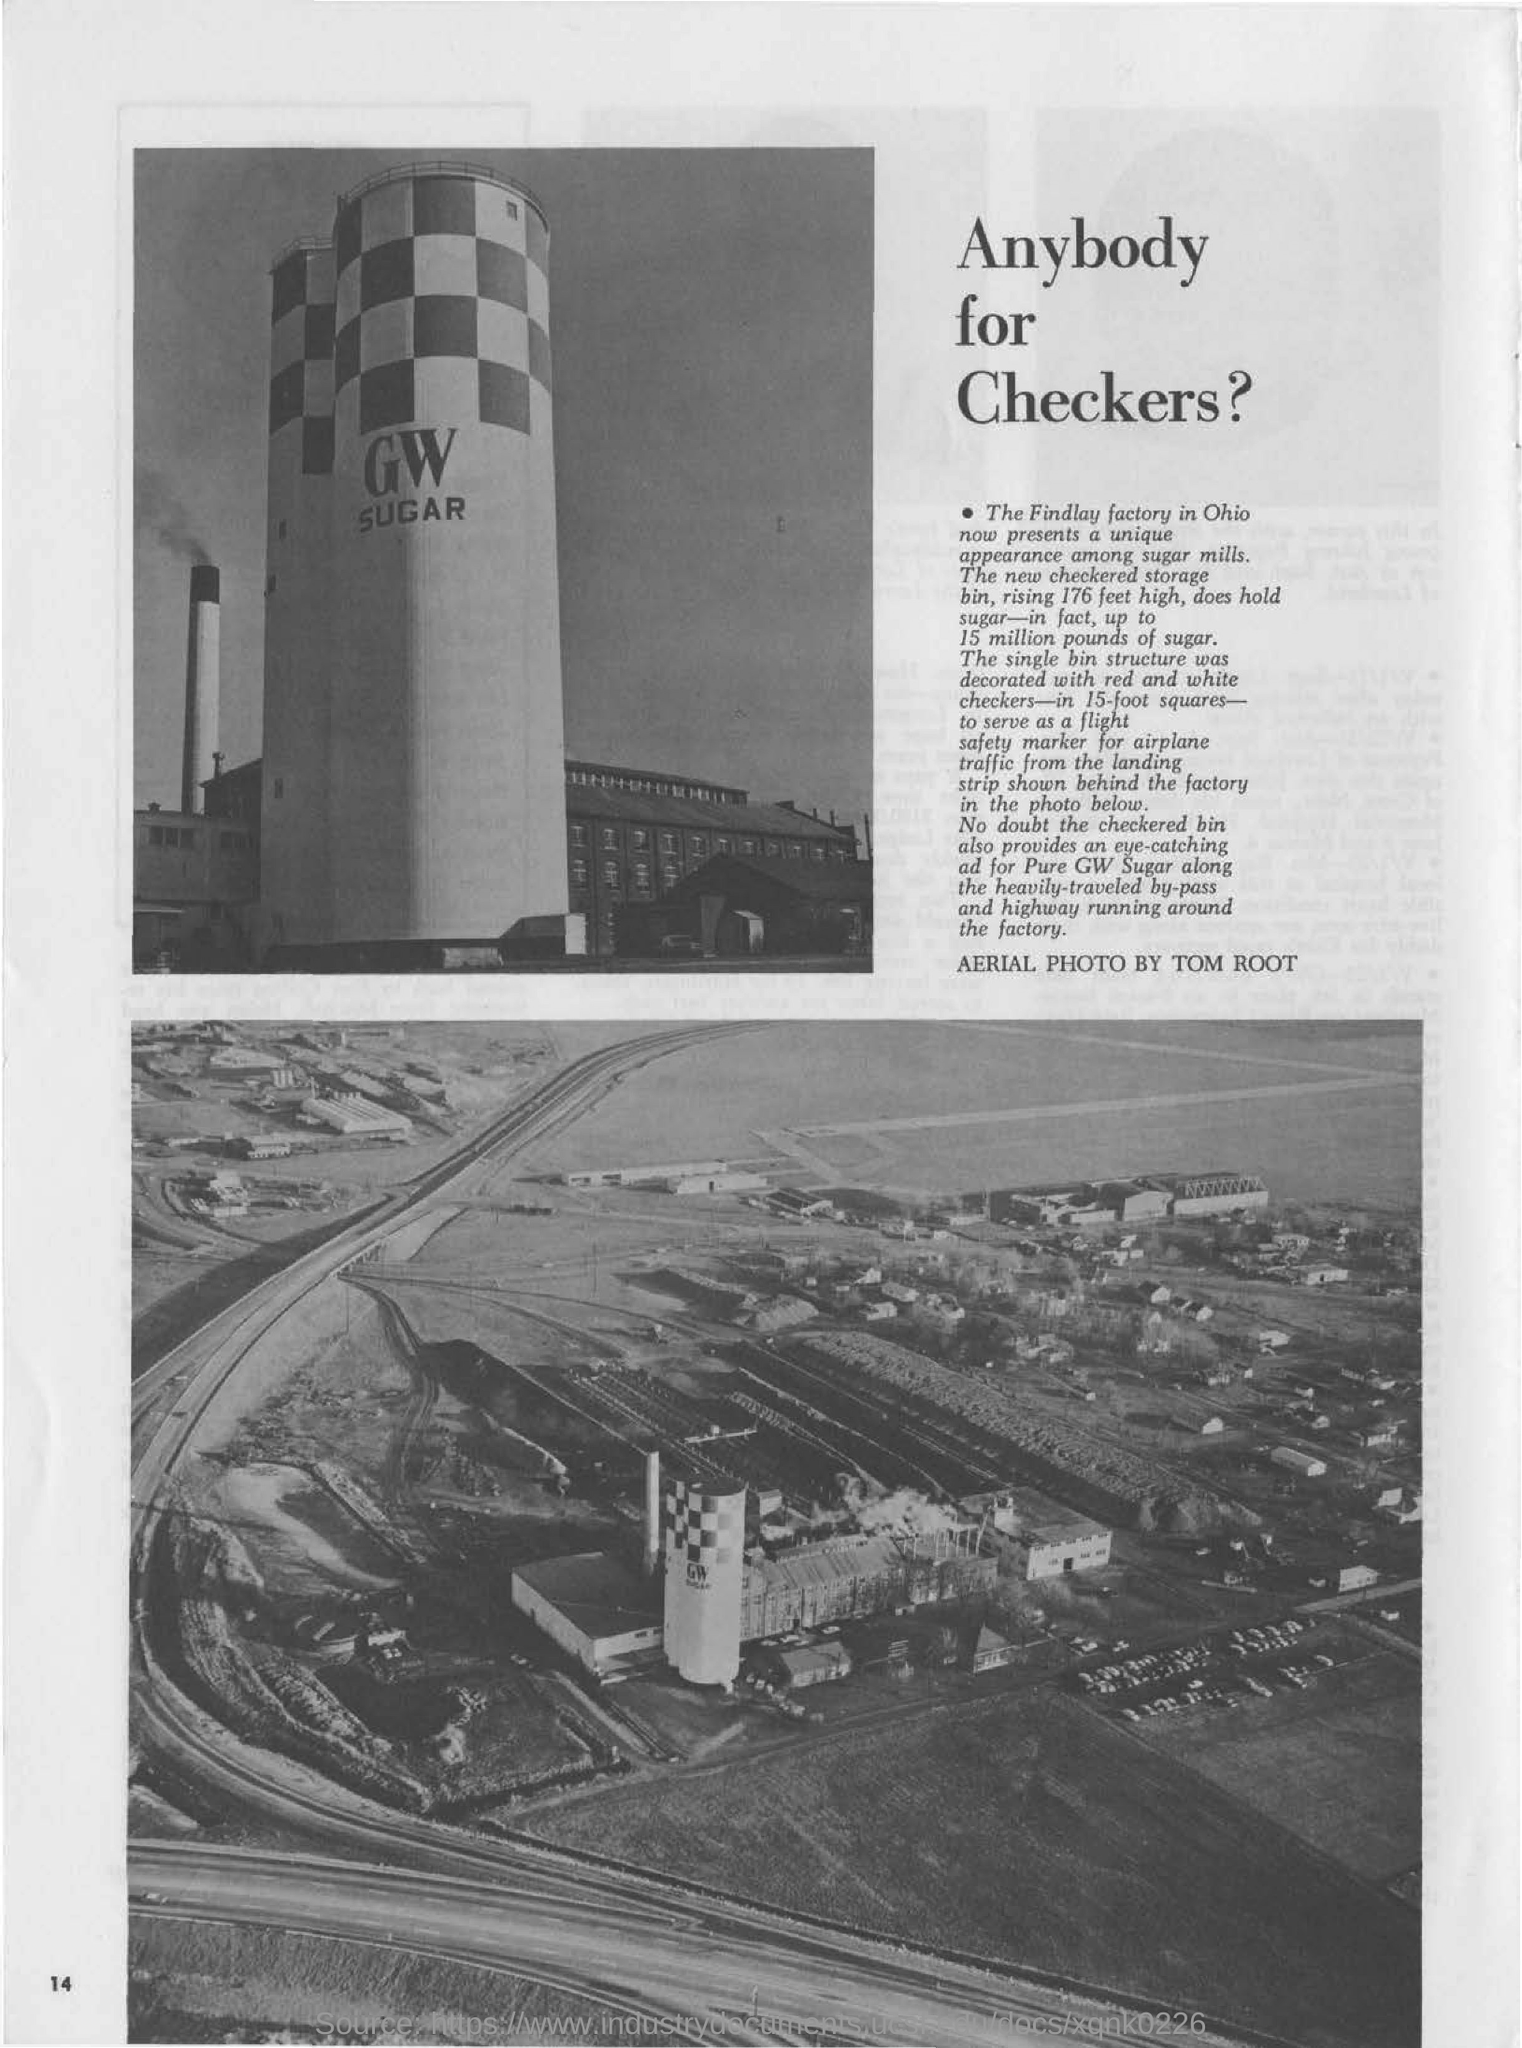Specify some key components in this picture. The new checkered storage bin has the capacity to hold 15 million pounds of sugar. It is known that Tom Root has clicked the aerial photo. The new checkered storage bin is 176 feet tall. The image depicts the storage bin of the Findlay factory. The headline of the news is unknown, and anyone is invited to play Checkers. 